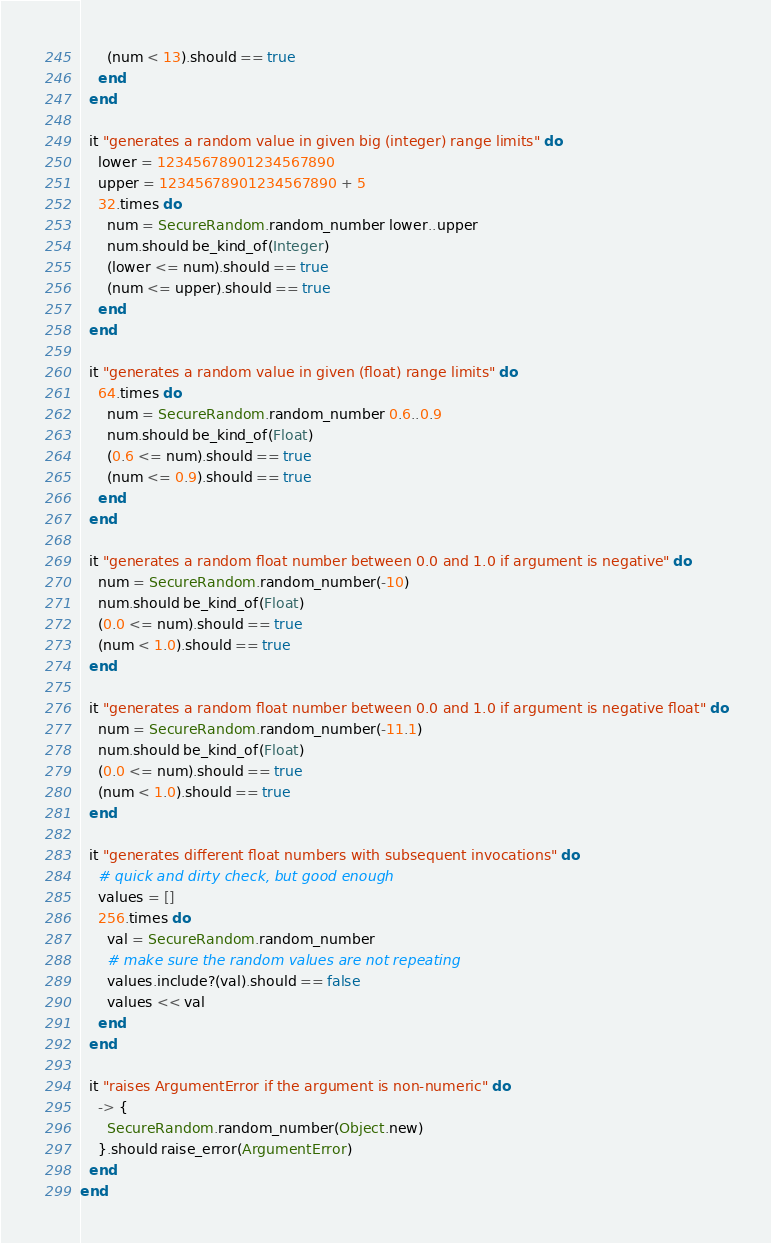Convert code to text. <code><loc_0><loc_0><loc_500><loc_500><_Ruby_>      (num < 13).should == true
    end
  end

  it "generates a random value in given big (integer) range limits" do
    lower = 12345678901234567890
    upper = 12345678901234567890 + 5
    32.times do
      num = SecureRandom.random_number lower..upper
      num.should be_kind_of(Integer)
      (lower <= num).should == true
      (num <= upper).should == true
    end
  end

  it "generates a random value in given (float) range limits" do
    64.times do
      num = SecureRandom.random_number 0.6..0.9
      num.should be_kind_of(Float)
      (0.6 <= num).should == true
      (num <= 0.9).should == true
    end
  end

  it "generates a random float number between 0.0 and 1.0 if argument is negative" do
    num = SecureRandom.random_number(-10)
    num.should be_kind_of(Float)
    (0.0 <= num).should == true
    (num < 1.0).should == true
  end

  it "generates a random float number between 0.0 and 1.0 if argument is negative float" do
    num = SecureRandom.random_number(-11.1)
    num.should be_kind_of(Float)
    (0.0 <= num).should == true
    (num < 1.0).should == true
  end

  it "generates different float numbers with subsequent invocations" do
    # quick and dirty check, but good enough
    values = []
    256.times do
      val = SecureRandom.random_number
      # make sure the random values are not repeating
      values.include?(val).should == false
      values << val
    end
  end

  it "raises ArgumentError if the argument is non-numeric" do
    -> {
      SecureRandom.random_number(Object.new)
    }.should raise_error(ArgumentError)
  end
end
</code> 